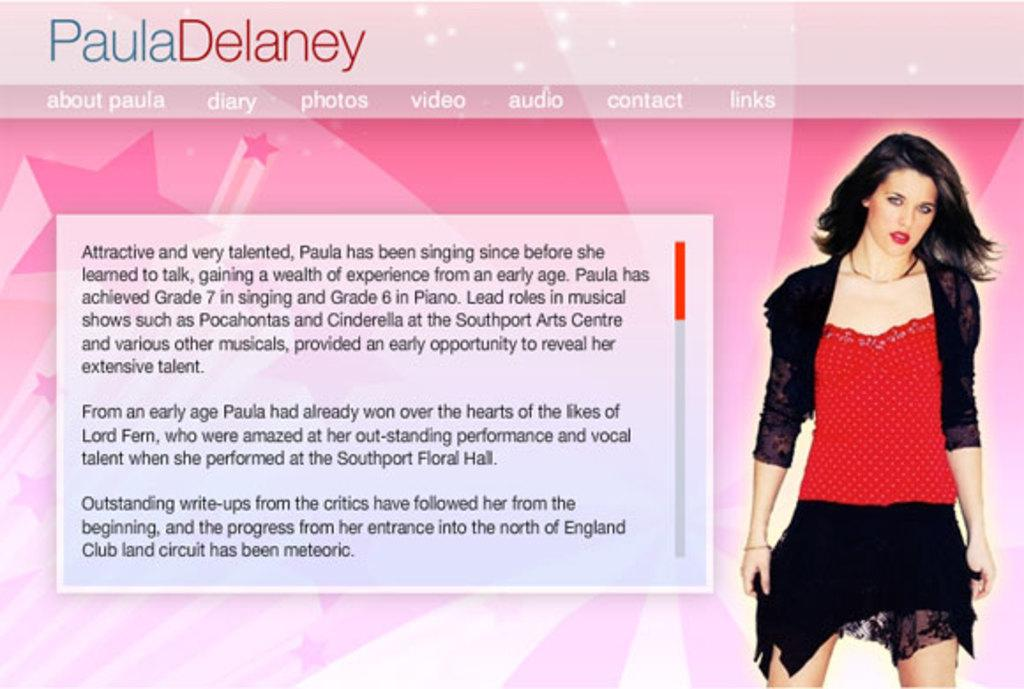What type of image is being displayed in the screenshot? The image is a screenshot of a website. Can you describe any people or characters visible in the screenshot? Yes, there is a girl on the right side of the screenshot. What type of head can be seen on the girl in the image? There is no specific mention of a head or any headgear in the provided facts, so we cannot determine the type of head present in the image. 